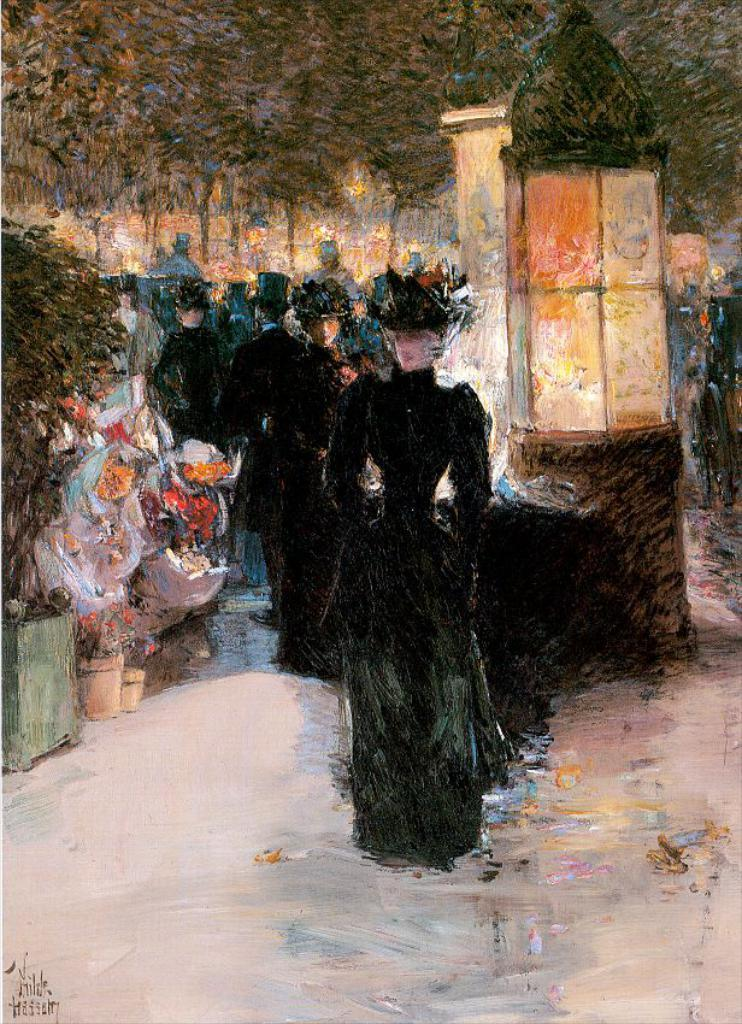Who or what is depicted in the painting? There are people in the painting. What type of plants can be seen in the painting? There are house plants in the painting. Are there any natural elements in the painting? Yes, there is a tree in the painting. What type of silk is being used to create the tree in the painting? There is no silk present in the painting, as it is a depiction of a tree rather than a fabric. 